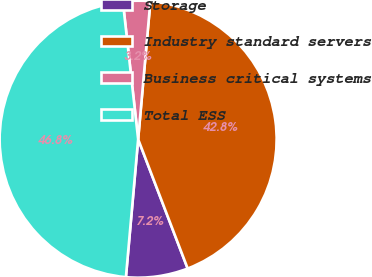Convert chart to OTSL. <chart><loc_0><loc_0><loc_500><loc_500><pie_chart><fcel>Storage<fcel>Industry standard servers<fcel>Business critical systems<fcel>Total ESS<nl><fcel>7.23%<fcel>42.77%<fcel>3.17%<fcel>46.83%<nl></chart> 